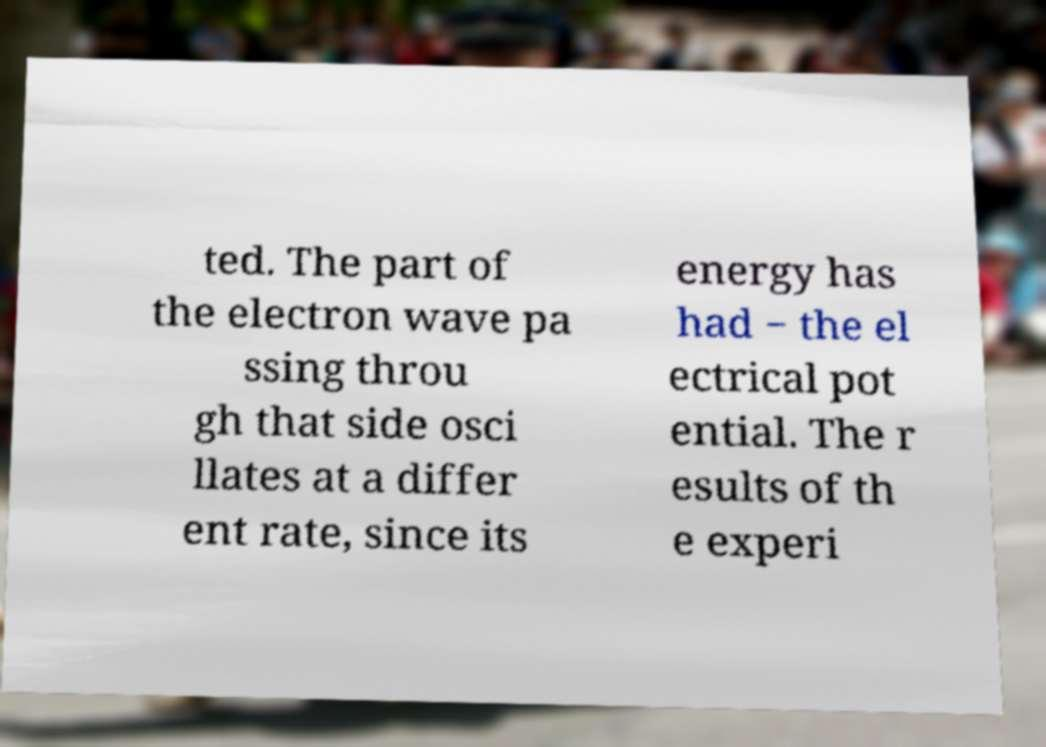Can you read and provide the text displayed in the image?This photo seems to have some interesting text. Can you extract and type it out for me? ted. The part of the electron wave pa ssing throu gh that side osci llates at a differ ent rate, since its energy has had − the el ectrical pot ential. The r esults of th e experi 